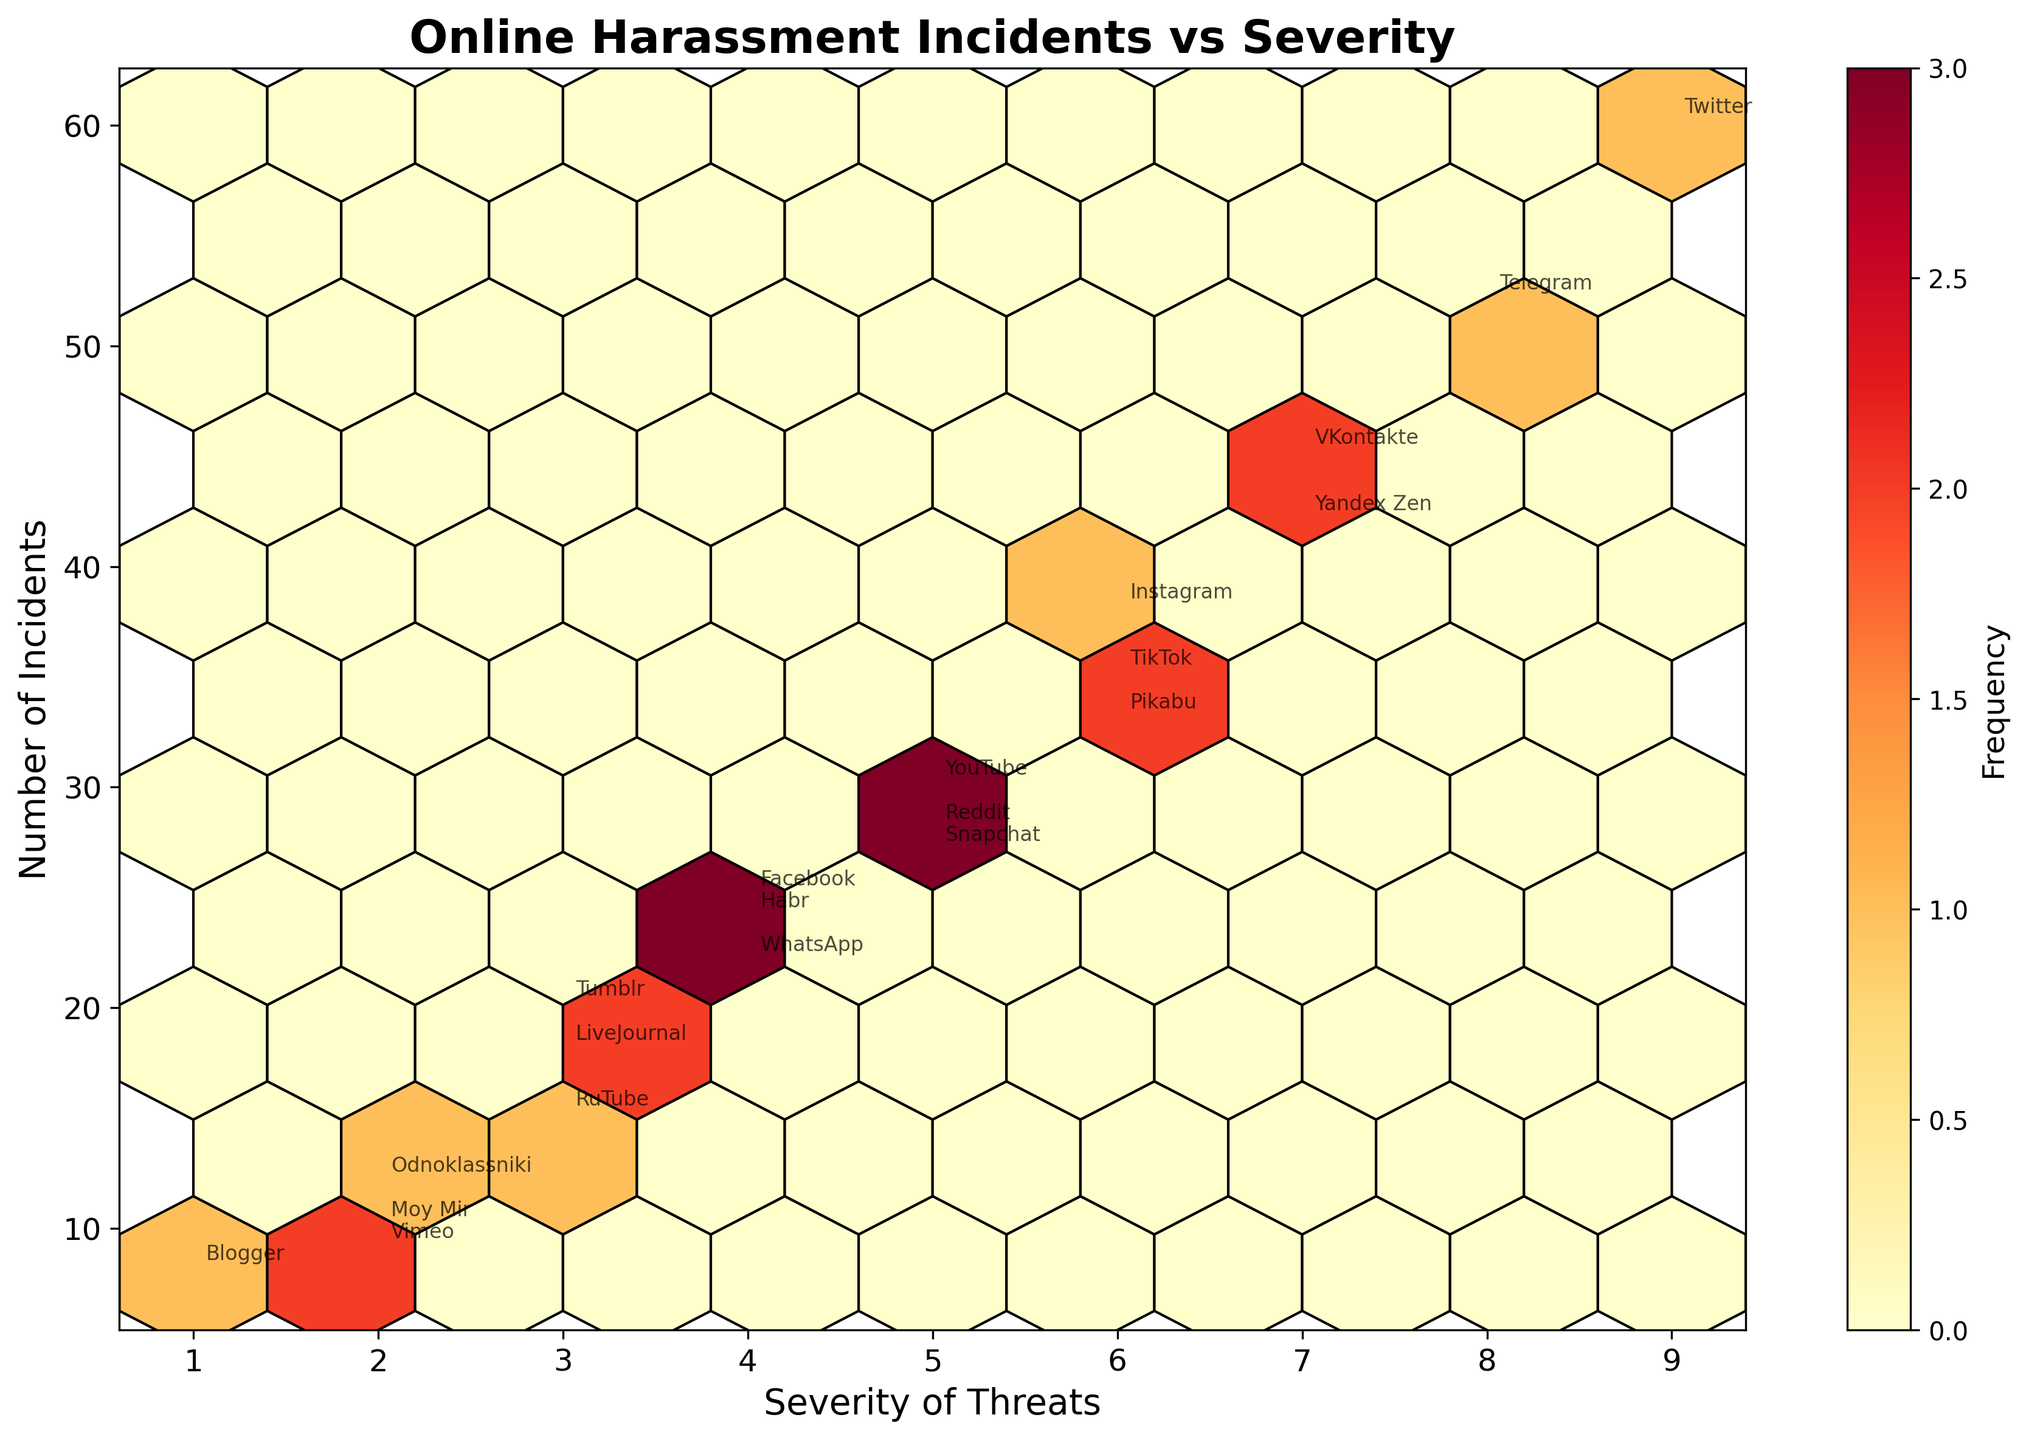what is the title of the plot? The title of the plot is shown at the top center of the figure in a larger and bold font. It reads 'Online Harassment Incidents vs Severity'.
Answer: Online Harassment Incidents vs Severity What does the color of the hexagons represent in the plot? The color of the hexagons represents the frequency of incidents. Darker colors indicate higher frequencies.
Answer: Frequency Which platform has the highest number of incidents? By observing the y-axis and the annotations, Twitter shows up at the highest y-value with 60 incidents, indicating it has the highest number of incidents.
Answer: Twitter How many platforms have severity levels 7 and above? Platforms with severity levels 7 and above are VKontakte, Telegram, and Yandex Zen. Counting these platforms gives us a total of 3.
Answer: 3 What is the severity level for Instagram? By locating Instagram on the plot, it shows that Instagram has a severity level of 6.
Answer: 6 Which hexbin has the darkest color and what does it represent? The hexbin with the darkest color (indicating the highest frequency) is around the combination of severity level 8 and incidents 52, which represents Telegram.
Answer: Telegram Is there any platform with a severity level of 1 and if so, how many incidents? By looking at the x-axis for severity level 1 and checking annotations around it, Blogger shows up with 8 incidents.
Answer: Blogger, 8 How many platforms are associated with severity level 5? Platforms with severity level 5, annotated within the plot, are YouTube, Reddit, and Snapchat. Counting these platforms gives us a total of 3.
Answer: 3 Compare the platforms with severity levels 3 and below in terms of their highest incident numbers. Which one has the most incidents? Platforms at severity levels 3 and below are LiveJournal, Odnoklassniki, Blogger, Tumblr, Vimeo, and Moy Mir. Among these, the highest incident number is 20, associated with Tumblr.
Answer: Tumblr What information does the colorbar provide? The colorbar next to the hexbin plot indicates the frequency of data points within the hexbins. It helps interpret how frequently certain severity and incident combinations occur.
Answer: Frequency 